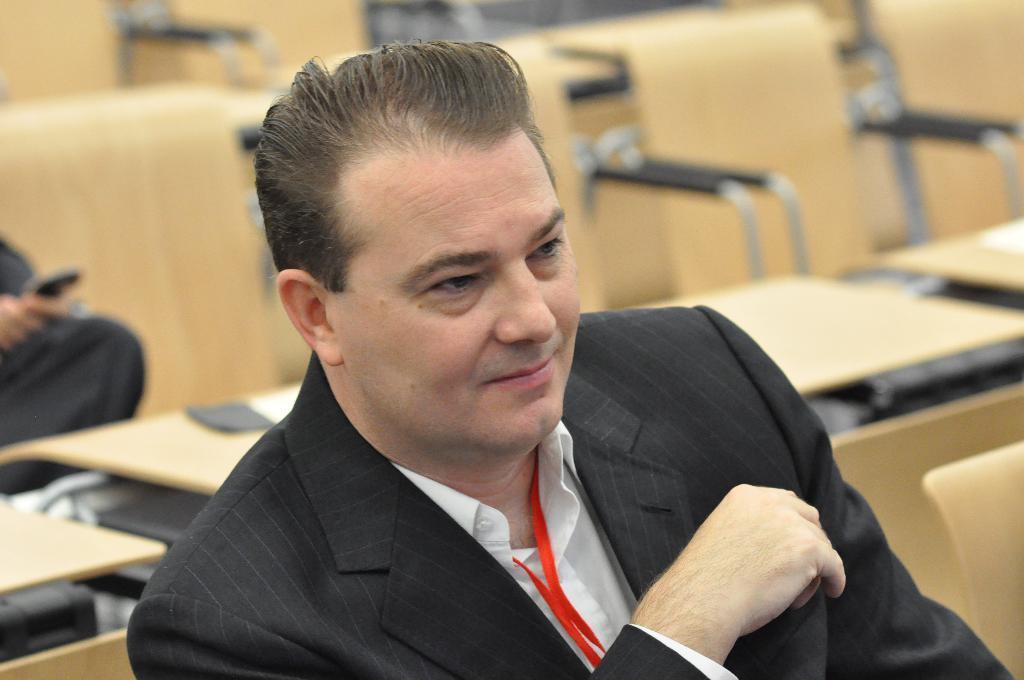Describe this image in one or two sentences. In this image we can see a man. In the back there are tables and chairs. And also there is another person on the left side. 